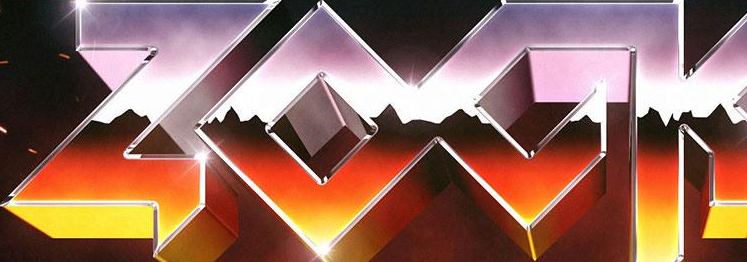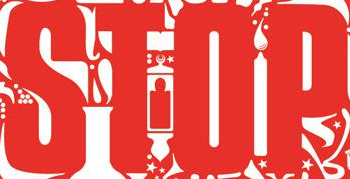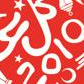Read the text content from these images in order, separated by a semicolon. ZOCK; STOP; 2010 